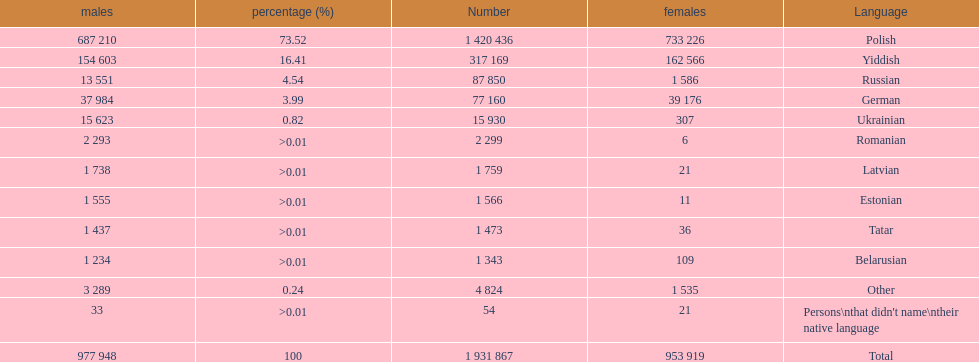Would you mind parsing the complete table? {'header': ['males', 'percentage (%)', 'Number', 'females', 'Language'], 'rows': [['687 210', '73.52', '1 420 436', '733 226', 'Polish'], ['154 603', '16.41', '317 169', '162 566', 'Yiddish'], ['13 551', '4.54', '87 850', '1 586', 'Russian'], ['37 984', '3.99', '77 160', '39 176', 'German'], ['15 623', '0.82', '15 930', '307', 'Ukrainian'], ['2 293', '>0.01', '2 299', '6', 'Romanian'], ['1 738', '>0.01', '1 759', '21', 'Latvian'], ['1 555', '>0.01', '1 566', '11', 'Estonian'], ['1 437', '>0.01', '1 473', '36', 'Tatar'], ['1 234', '>0.01', '1 343', '109', 'Belarusian'], ['3 289', '0.24', '4 824', '1 535', 'Other'], ['33', '>0.01', '54', '21', "Persons\\nthat didn't name\\ntheir native language"], ['977 948', '100', '1 931 867', '953 919', 'Total']]} Which language had the smallest number of females speaking it. Romanian. 